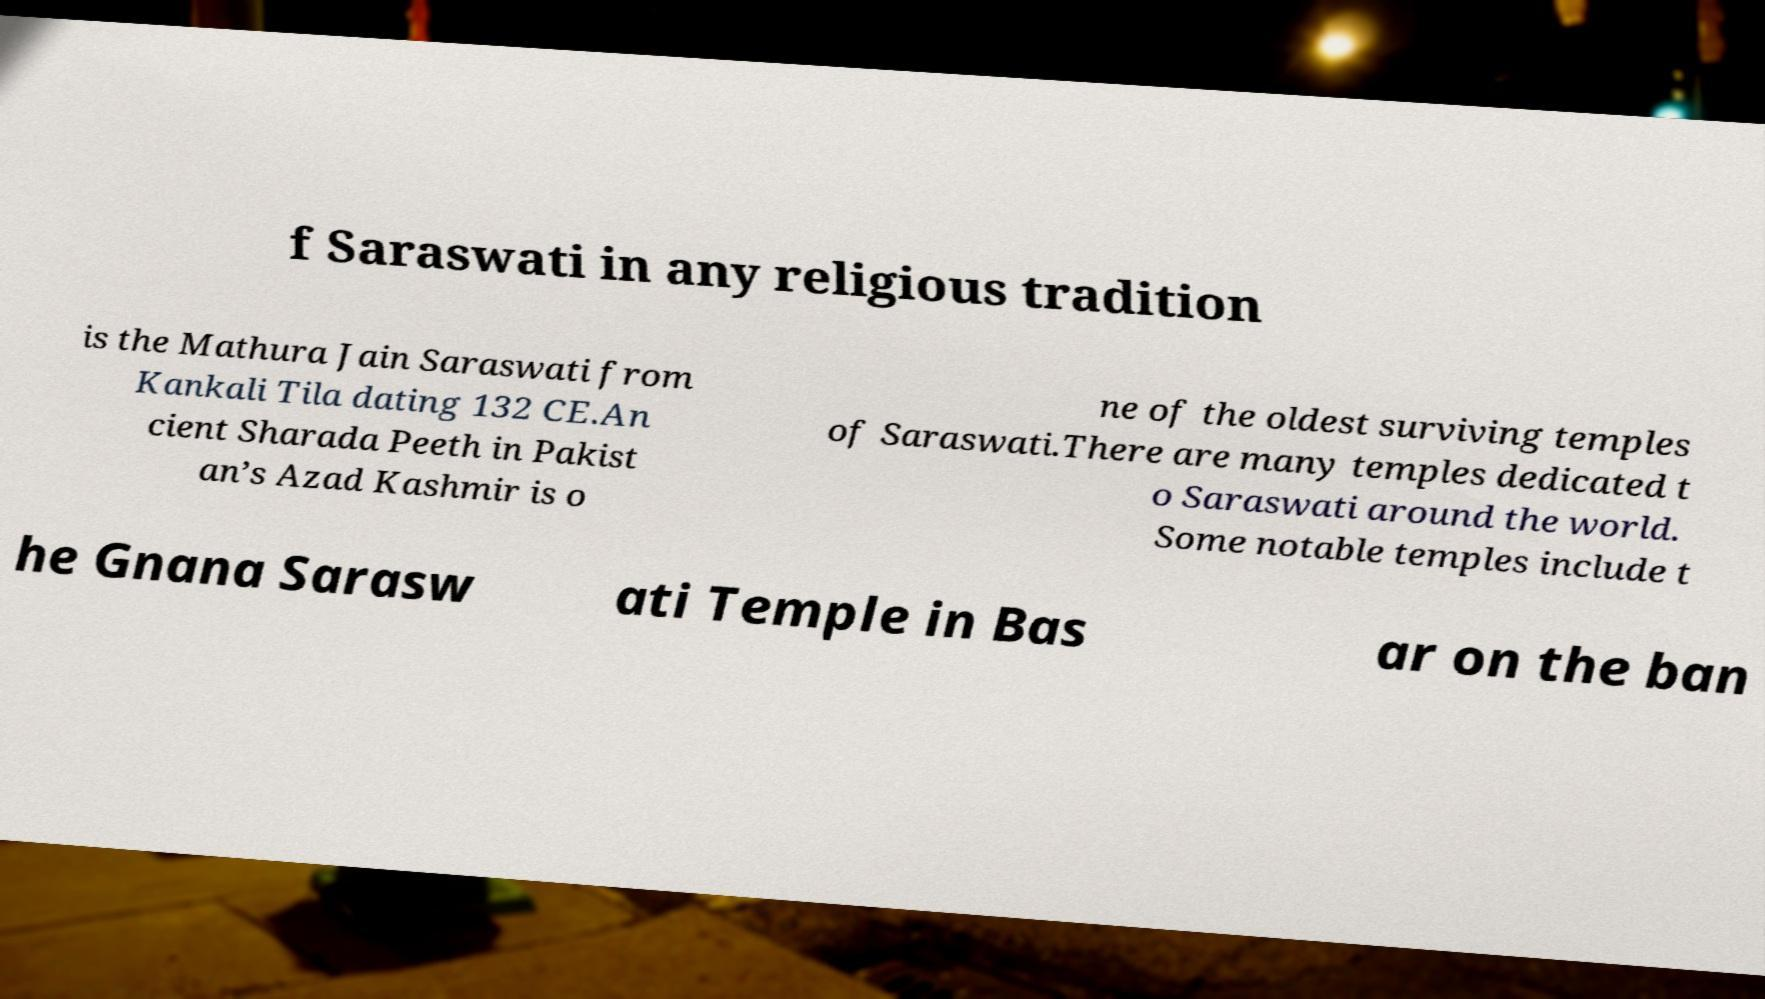Please identify and transcribe the text found in this image. f Saraswati in any religious tradition is the Mathura Jain Saraswati from Kankali Tila dating 132 CE.An cient Sharada Peeth in Pakist an’s Azad Kashmir is o ne of the oldest surviving temples of Saraswati.There are many temples dedicated t o Saraswati around the world. Some notable temples include t he Gnana Sarasw ati Temple in Bas ar on the ban 